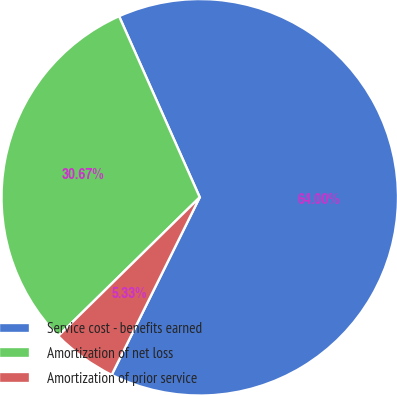<chart> <loc_0><loc_0><loc_500><loc_500><pie_chart><fcel>Service cost - benefits earned<fcel>Amortization of net loss<fcel>Amortization of prior service<nl><fcel>64.0%<fcel>30.67%<fcel>5.33%<nl></chart> 